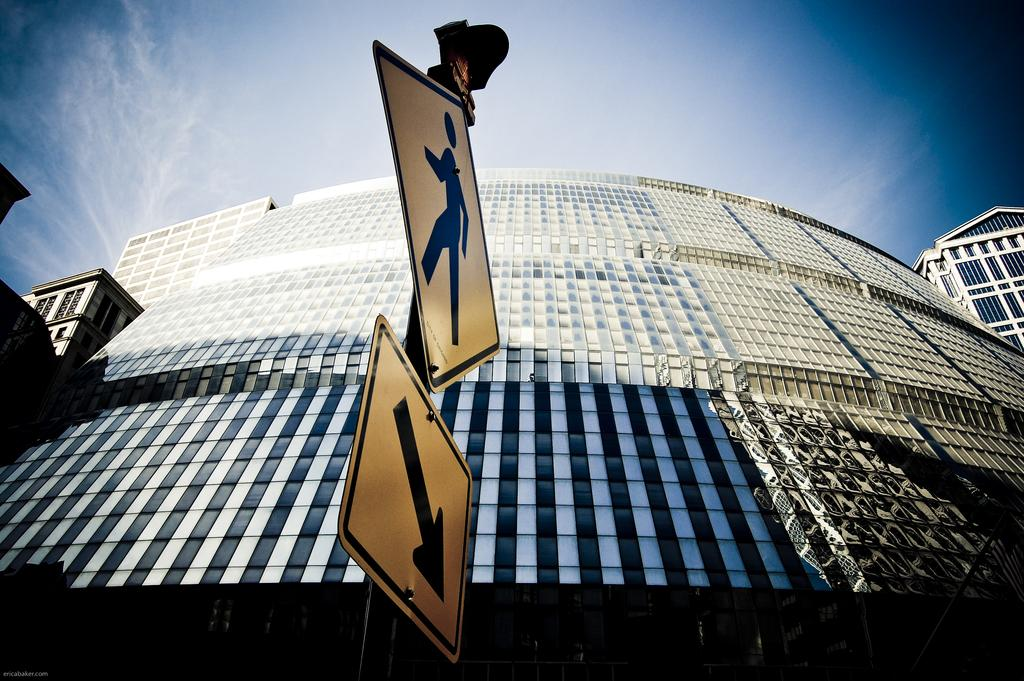What is located in the foreground of the picture? There are sign boards in the foreground of the picture. How are the sign boards positioned? The sign boards are attached to a pole. What can be seen in the center of the picture? There are buildings in the center of the picture. What is the condition of the sky in the picture? The sky is partially cloudy. Can you tell me how much rice is being cooked in the river in the image? There is no rice or river present in the image; it features sign boards, buildings, and a partially cloudy sky. 